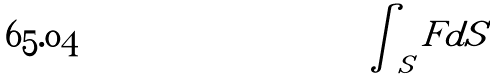<formula> <loc_0><loc_0><loc_500><loc_500>\int _ { S } F d S</formula> 